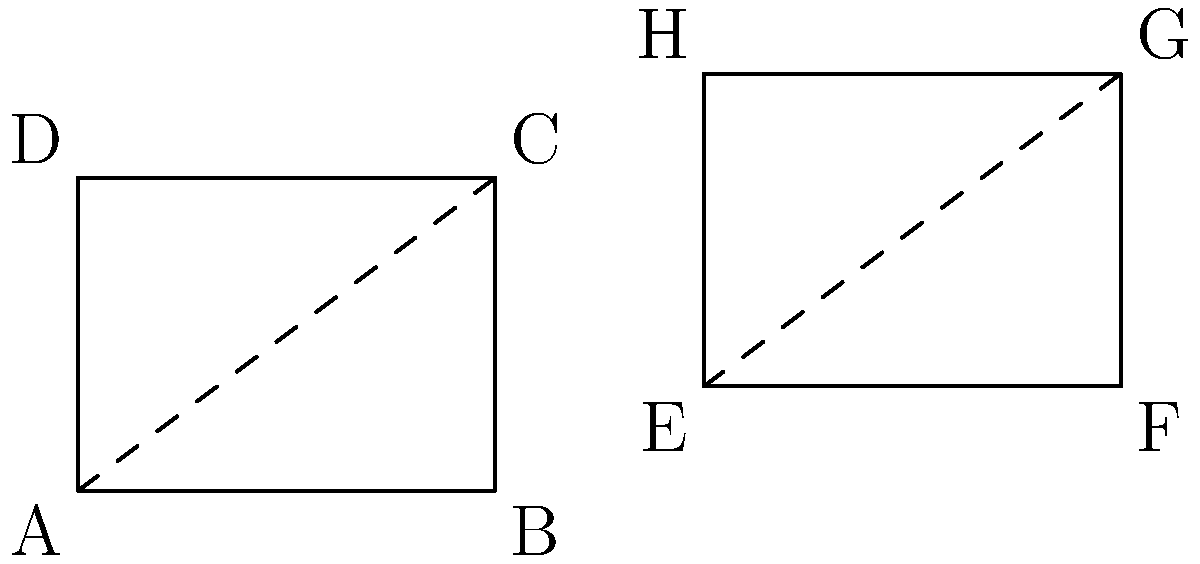In the architectural blueprint for a tech company's headquarters, two rectangular sections ABCD and EFGH are shown. Given that the diagonal AC in rectangle ABCD is congruent to the diagonal EG in rectangle EFGH, and that AB = 4 units and BC = 3 units, what is the area of rectangle EFGH? Let's approach this step-by-step:

1) First, we need to calculate the length of diagonal AC in rectangle ABCD.
   We can use the Pythagorean theorem:
   $$AC^2 = AB^2 + BC^2 = 4^2 + 3^2 = 16 + 9 = 25$$
   $$AC = \sqrt{25} = 5$$

2) Since diagonal EG is congruent to AC, we know that EG = 5 units.

3) Now, let's denote the width of EFGH as x and its height as y.
   We can set up another Pythagorean theorem equation:
   $$EG^2 = EF^2 + FG^2$$
   $$5^2 = x^2 + y^2$$
   $$25 = x^2 + y^2$$

4) We need one more piece of information to solve for x and y. 
   We can use the fact that EFGH is similar to ABCD, as they are both rectangles with congruent diagonals.
   The ratio of their sides must be the same as the ratio of their diagonals, which is 1:1.

   Therefore: $\frac{x}{4} = \frac{y}{3}$
   Cross multiply: $3x = 4y$

5) Now we have two equations:
   $$x^2 + y^2 = 25$$
   $$3x = 4y$$

6) From the second equation: $x = \frac{4y}{3}$
   Substitute this into the first equation:
   $$(\frac{4y}{3})^2 + y^2 = 25$$
   $$\frac{16y^2}{9} + y^2 = 25$$
   $$\frac{16y^2 + 9y^2}{9} = 25$$
   $$\frac{25y^2}{9} = 25$$
   $$y^2 = 9$$
   $$y = 3$$

7) If y = 3, then from $3x = 4y$, we can calculate x:
   $$3x = 4(3)$$
   $$3x = 12$$
   $$x = 4$$

8) The area of rectangle EFGH is therefore:
   $$Area = x * y = 4 * 3 = 12$$ square units
Answer: 12 square units 